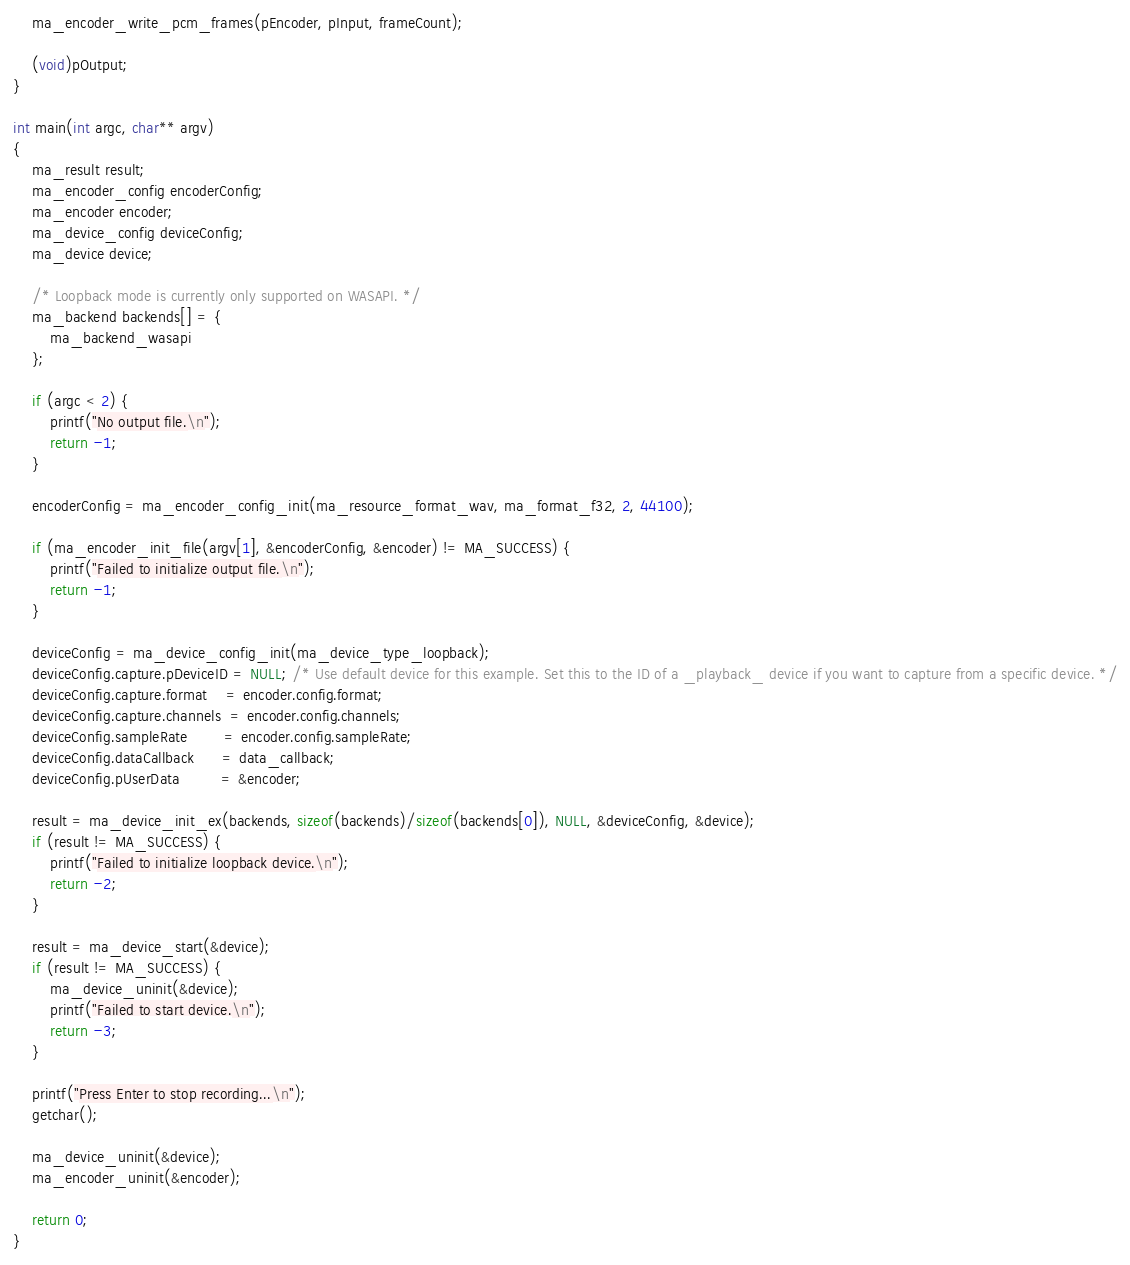Convert code to text. <code><loc_0><loc_0><loc_500><loc_500><_C_>
    ma_encoder_write_pcm_frames(pEncoder, pInput, frameCount);

    (void)pOutput;
}

int main(int argc, char** argv)
{
    ma_result result;
    ma_encoder_config encoderConfig;
    ma_encoder encoder;
    ma_device_config deviceConfig;
    ma_device device;

    /* Loopback mode is currently only supported on WASAPI. */
    ma_backend backends[] = {
        ma_backend_wasapi
    };

    if (argc < 2) {
        printf("No output file.\n");
        return -1;
    }

    encoderConfig = ma_encoder_config_init(ma_resource_format_wav, ma_format_f32, 2, 44100);

    if (ma_encoder_init_file(argv[1], &encoderConfig, &encoder) != MA_SUCCESS) {
        printf("Failed to initialize output file.\n");
        return -1;
    }

    deviceConfig = ma_device_config_init(ma_device_type_loopback);
    deviceConfig.capture.pDeviceID = NULL; /* Use default device for this example. Set this to the ID of a _playback_ device if you want to capture from a specific device. */
    deviceConfig.capture.format    = encoder.config.format;
    deviceConfig.capture.channels  = encoder.config.channels;
    deviceConfig.sampleRate        = encoder.config.sampleRate;
    deviceConfig.dataCallback      = data_callback;
    deviceConfig.pUserData         = &encoder;

    result = ma_device_init_ex(backends, sizeof(backends)/sizeof(backends[0]), NULL, &deviceConfig, &device);
    if (result != MA_SUCCESS) {
        printf("Failed to initialize loopback device.\n");
        return -2;
    }

    result = ma_device_start(&device);
    if (result != MA_SUCCESS) {
        ma_device_uninit(&device);
        printf("Failed to start device.\n");
        return -3;
    }

    printf("Press Enter to stop recording...\n");
    getchar();
    
    ma_device_uninit(&device);
    ma_encoder_uninit(&encoder);

    return 0;
}
</code> 